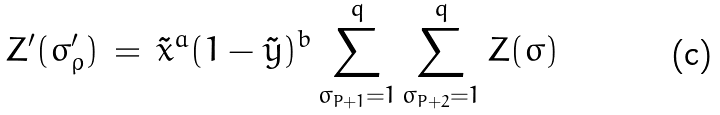Convert formula to latex. <formula><loc_0><loc_0><loc_500><loc_500>Z ^ { \prime } ( { \sigma } ^ { \prime } _ { \rho } ) \, = \, \tilde { x } ^ { a } ( 1 - \tilde { y } ) ^ { b } \sum _ { \sigma _ { P + 1 } = 1 } ^ { q } \sum _ { \sigma _ { P + 2 } = 1 } ^ { q } Z ( { \sigma } )</formula> 